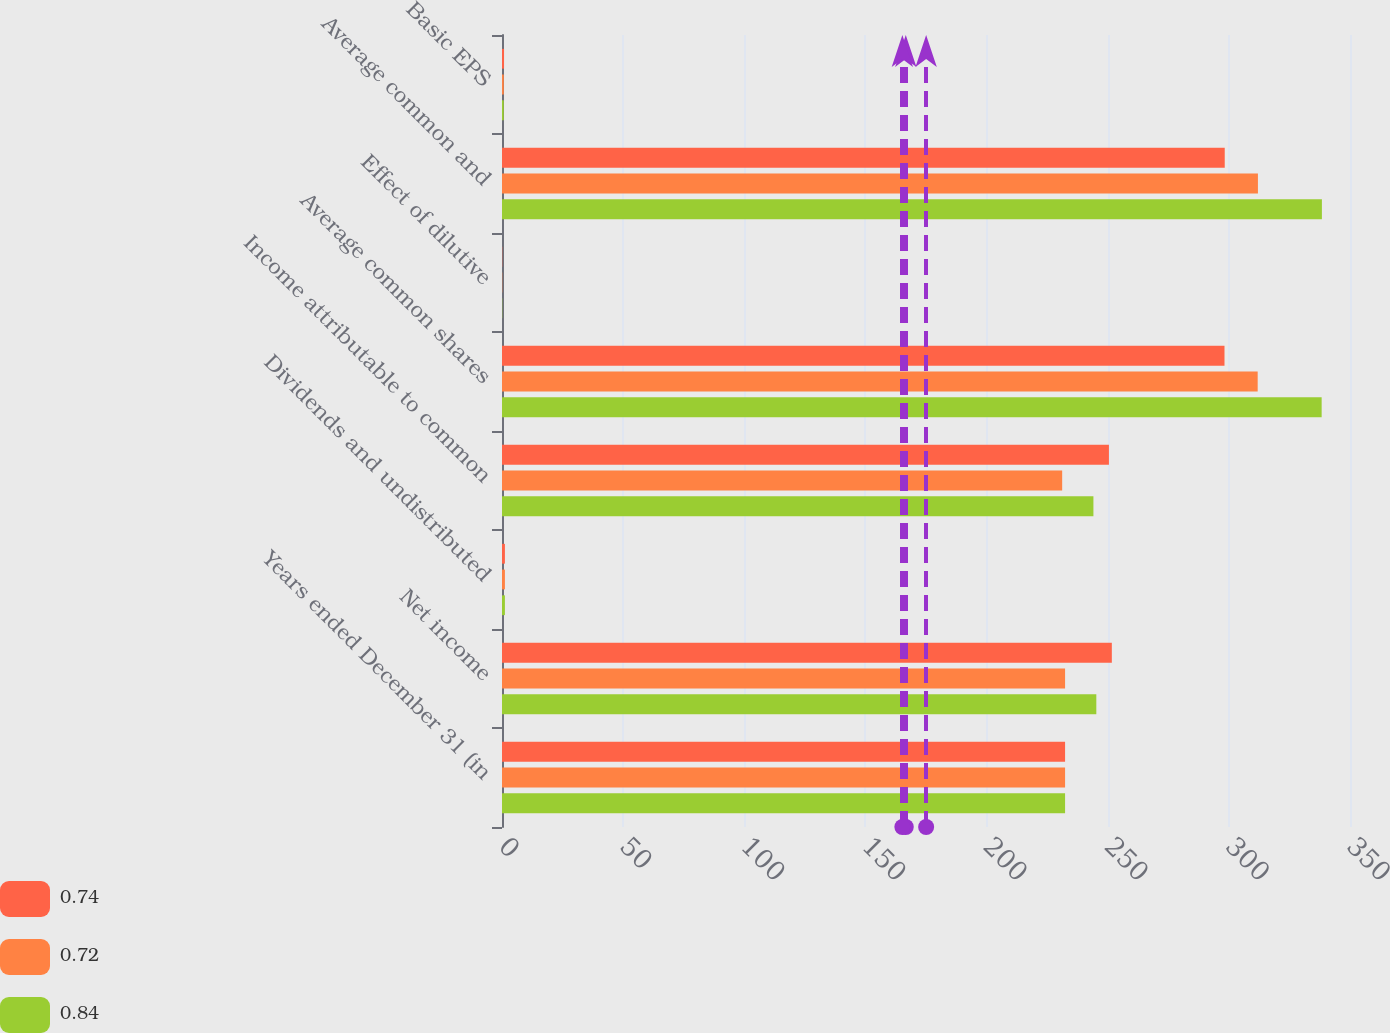Convert chart to OTSL. <chart><loc_0><loc_0><loc_500><loc_500><stacked_bar_chart><ecel><fcel>Years ended December 31 (in<fcel>Net income<fcel>Dividends and undistributed<fcel>Income attributable to common<fcel>Average common shares<fcel>Effect of dilutive<fcel>Average common and<fcel>Basic EPS<nl><fcel>0.74<fcel>232.4<fcel>251.7<fcel>1.2<fcel>250.5<fcel>298.2<fcel>0.1<fcel>298.3<fcel>0.84<nl><fcel>0.72<fcel>232.4<fcel>232.4<fcel>1.2<fcel>231.2<fcel>311.9<fcel>0.1<fcel>312<fcel>0.74<nl><fcel>0.84<fcel>232.4<fcel>245.3<fcel>1.2<fcel>244.1<fcel>338.3<fcel>0.1<fcel>338.4<fcel>0.72<nl></chart> 